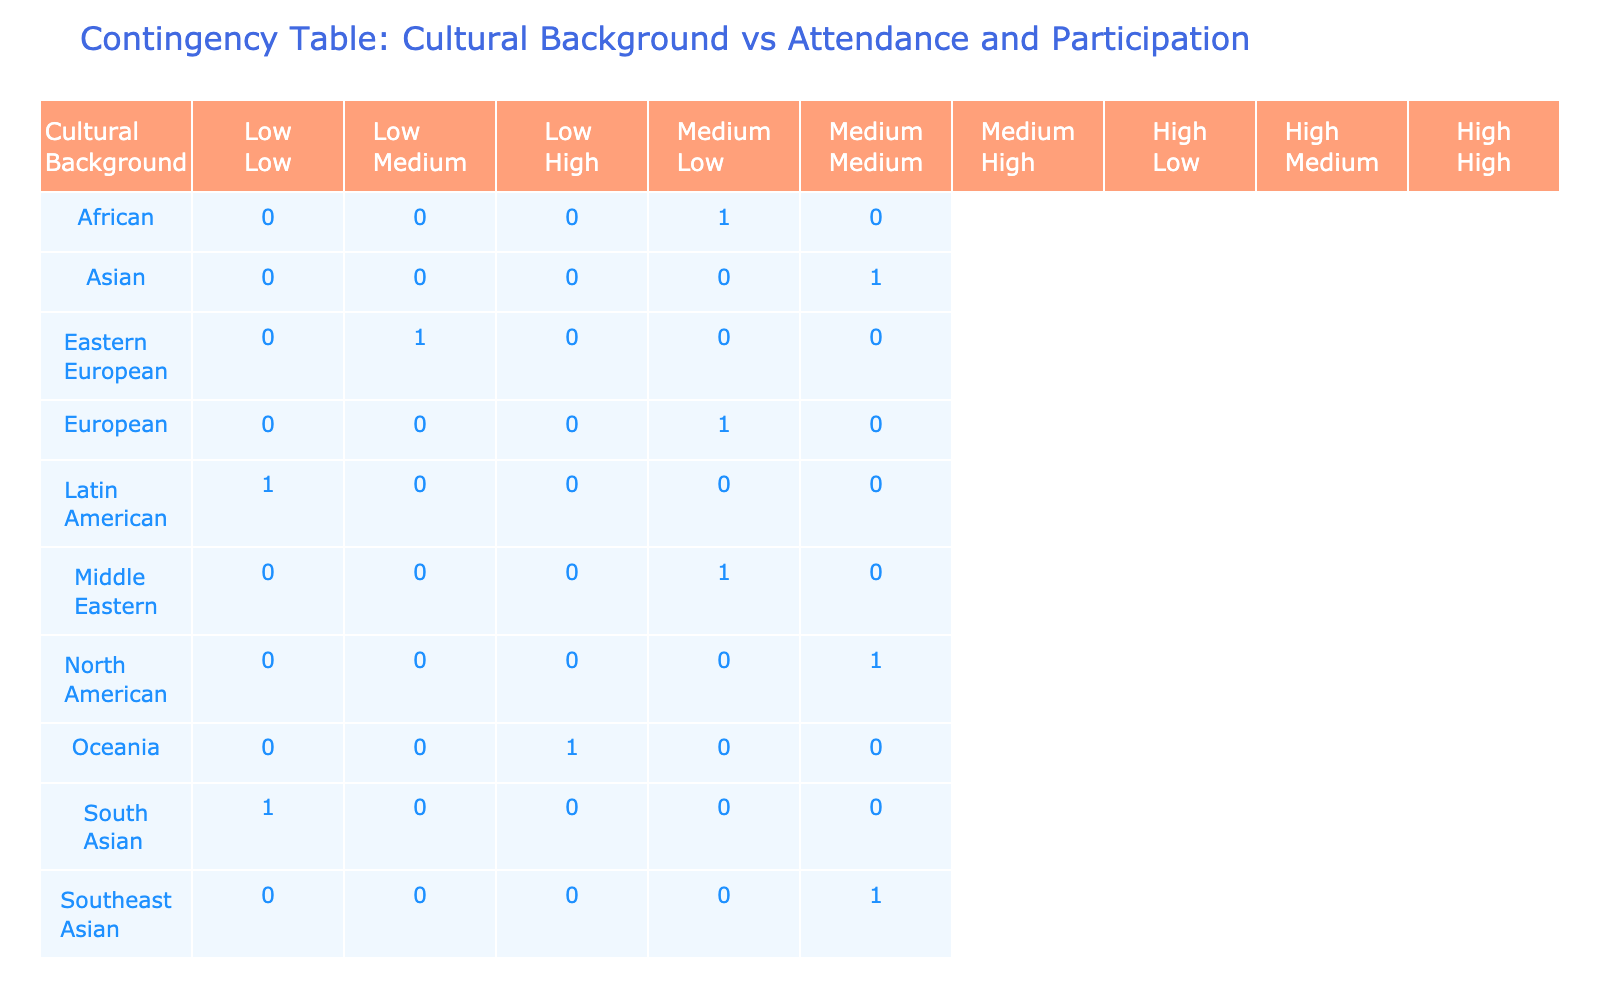What is the attendance rate for North American participants? According to the table, the attendance rate for North American participants is listed directly under their cultural background. It is 80%.
Answer: 80% Which cultural background has the lowest participation level? Upon reviewing the table, I see that the Latin American cultural group has the lowest participation level categorized as low.
Answer: Latin American How many cultural backgrounds have a high participation level? By examining the table, I can see that there are four cultural backgrounds (Asian, North American, Oceania, Southeast Asian) with a high participation level.
Answer: 4 Is it true that all African participants have a medium attendance rate? The table shows that African participants have an attendance rate of 65% and a medium participation level, so it is not strictly fair to conclude they are all medium. However, this is true based on the data presented.
Answer: Yes What is the average attendance rate of cultural backgrounds with a low participation level? The cultural backgrounds with low participation levels are Latin American and South Asian. Their attendance rates are 50% and 40%. To find the average: (50 + 40) / 2 = 45%.
Answer: 45% Which cultural background has the highest attendance rate? The table indicates the attendance rates for all cultural backgrounds, and I can see that Southeast Asian has the highest attendance rate at 85%.
Answer: Southeast Asian Do participants from Oceania have a higher attendance rate than those from Eastern Europe? By checking the attendance rates listed in the table, Oceania has a rate of 70% while Eastern Europe has a rate of 45%. Since 70% is higher than 45%, the statement is true.
Answer: Yes How many cultural backgrounds have a medium attendance rate? Looking closely at the table, I find those with medium attendance rates are European (60%), African (65%), Middle Eastern (55%), and Eastern European (45%). That totals four cultural backgrounds with medium attendance rates.
Answer: 4 If you look at high participation levels, which cultural backgrounds have more than 75% attendance? Analyzing the table, I notice that among the cultural backgrounds with high participation, North American (80%) and Southeast Asian (85%) exceed 75% in their attendance rates, meaning two cultural backgrounds meet the criteria.
Answer: 2 